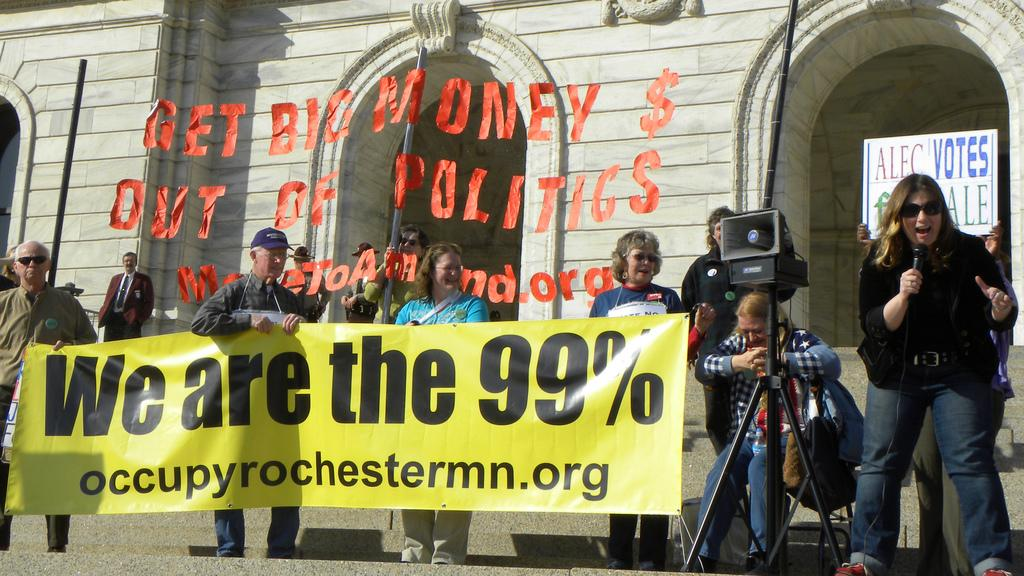What are the people in the center of the image doing? The people in the center of the image are holding a banner. What can be seen in the background of the image? There is a building in the background of the image. What is the lady on the right side of the image holding? The lady on the right side of the image is holding a mic. How many passengers are sitting in the front of the image? There is no reference to a vehicle or passengers in the image, so it is not possible to answer that question. 